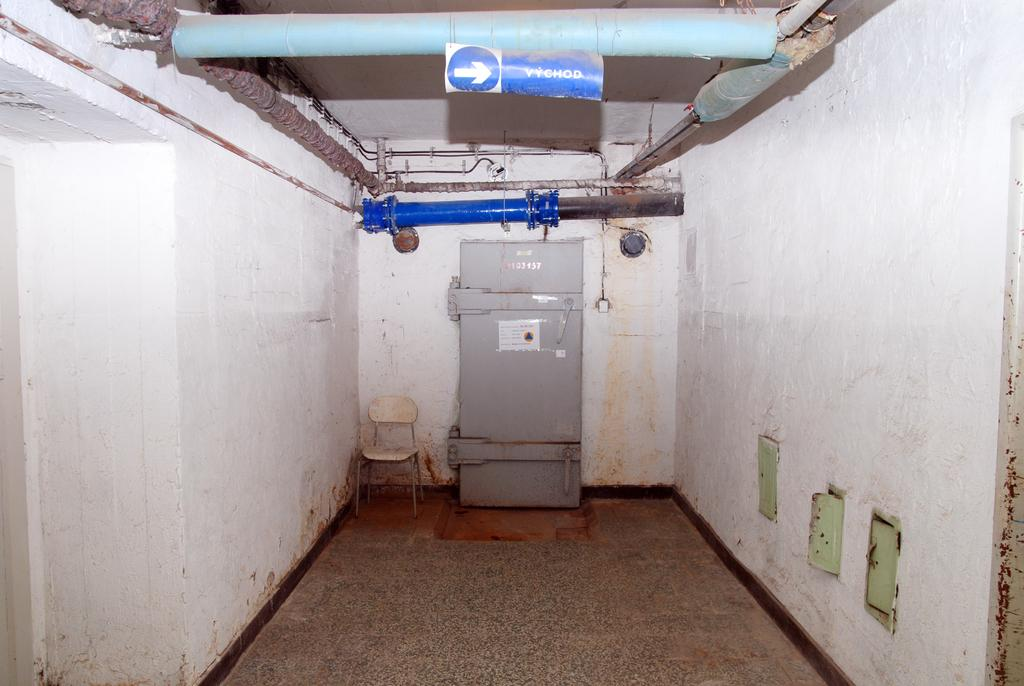<image>
Provide a brief description of the given image. A door below a sign that says Vychod. 